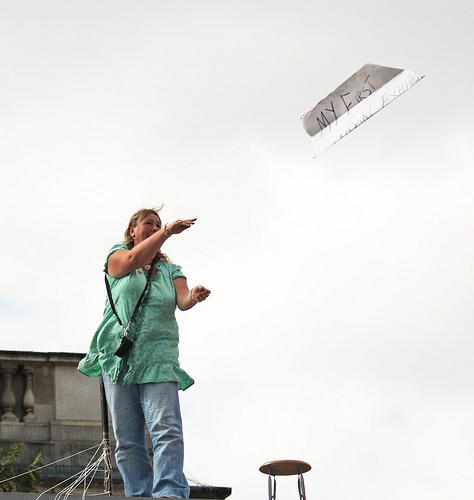<image>
Is there a kite next to the woman? No. The kite is not positioned next to the woman. They are located in different areas of the scene. 